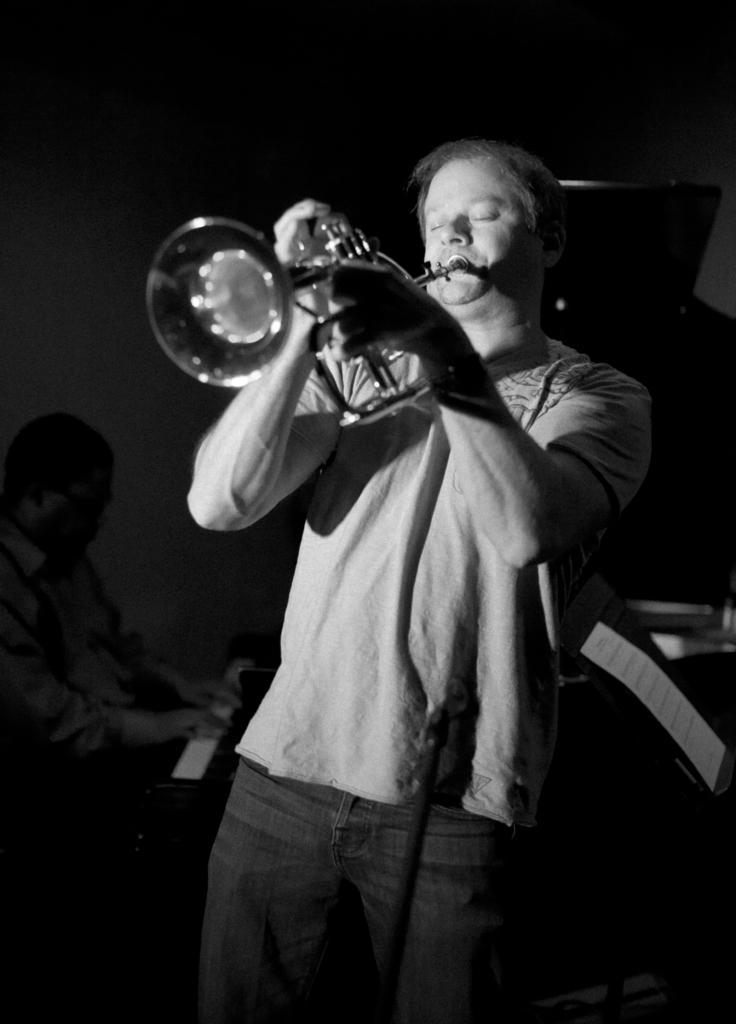Can you describe this image briefly? This is a black and white image. In the image, we can see a person playing a trumpet. On the left side of the image, we can see another person playing a piano. On the right side of the image, we can see a paper on the stand. 